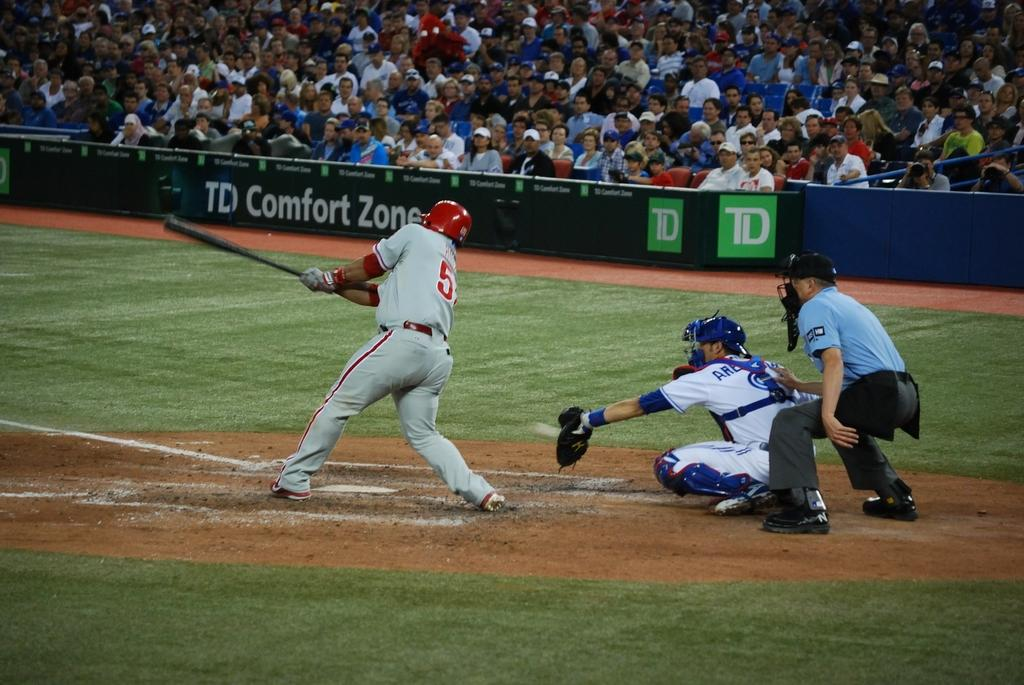<image>
Write a terse but informative summary of the picture. A man with a five on the back of his jersey is batting. 